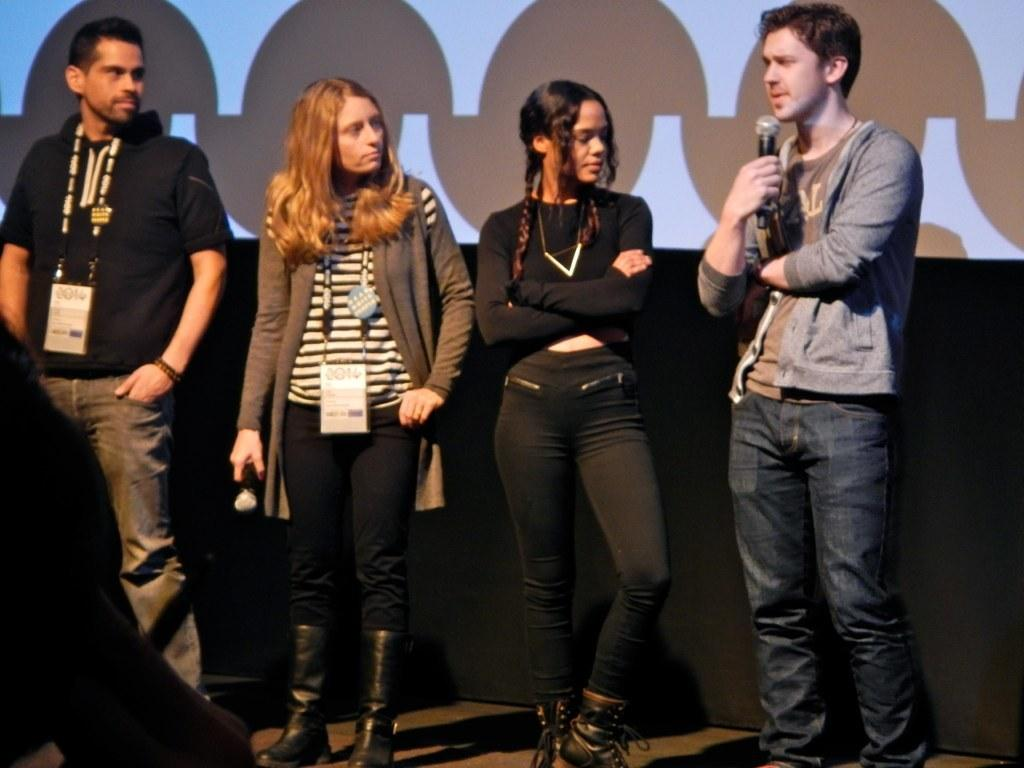How many people are present in the image? There are four people standing in the image. What is the surface on which the people are standing? The people are standing on the floor. Can you identify any specific objects being held by the people? Yes, a man is holding a microphone, and a woman is holding a microphone. What type of fog can be seen in the image? There is no fog present in the image. What type of laborer is visible in the image? There is no laborer present in the image. 